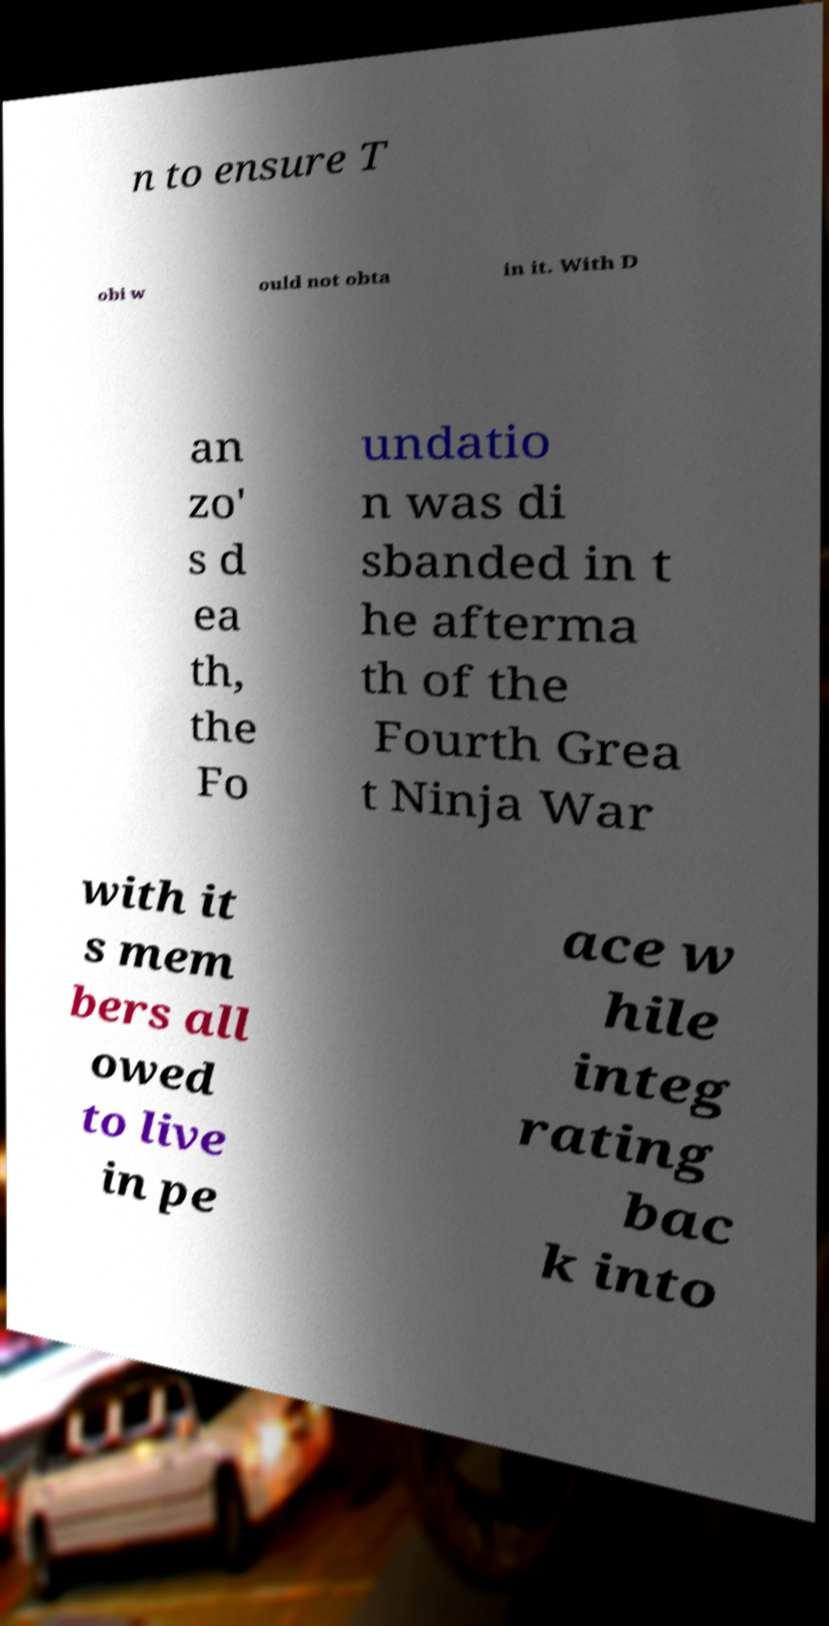Can you accurately transcribe the text from the provided image for me? n to ensure T obi w ould not obta in it. With D an zo' s d ea th, the Fo undatio n was di sbanded in t he afterma th of the Fourth Grea t Ninja War with it s mem bers all owed to live in pe ace w hile integ rating bac k into 